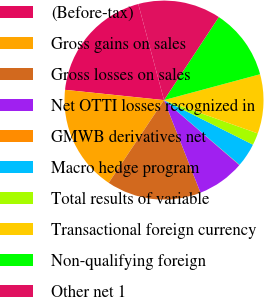Convert chart to OTSL. <chart><loc_0><loc_0><loc_500><loc_500><pie_chart><fcel>(Before-tax)<fcel>Gross gains on sales<fcel>Gross losses on sales<fcel>Net OTTI losses recognized in<fcel>GMWB derivatives net<fcel>Macro hedge program<fcel>Total results of variable<fcel>Transactional foreign currency<fcel>Non-qualifying foreign<fcel>Other net 1<nl><fcel>19.19%<fcel>17.27%<fcel>15.36%<fcel>7.7%<fcel>0.05%<fcel>3.88%<fcel>1.96%<fcel>9.62%<fcel>11.53%<fcel>13.45%<nl></chart> 